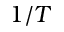Convert formula to latex. <formula><loc_0><loc_0><loc_500><loc_500>1 / T</formula> 